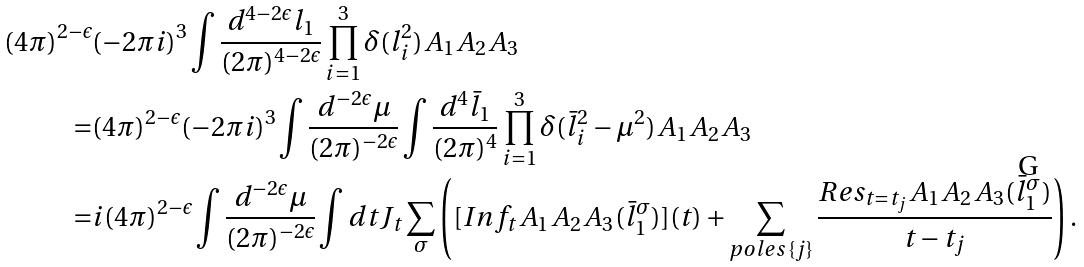<formula> <loc_0><loc_0><loc_500><loc_500>( 4 \pi ) ^ { 2 - \epsilon } & ( - 2 \pi i ) ^ { 3 } \int \frac { d ^ { 4 - 2 \epsilon } l _ { 1 } } { ( 2 \pi ) ^ { 4 - 2 \epsilon } } \prod _ { i = 1 } ^ { 3 } \delta ( l _ { i } ^ { 2 } ) A _ { 1 } A _ { 2 } A _ { 3 } \\ = & ( 4 \pi ) ^ { 2 - \epsilon } ( - 2 \pi i ) ^ { 3 } \int \frac { d ^ { - 2 \epsilon } \mu } { ( 2 \pi ) ^ { - 2 \epsilon } } \int \frac { d ^ { 4 } \bar { l } _ { 1 } } { ( 2 \pi ) ^ { 4 } } \prod _ { i = 1 } ^ { 3 } \delta ( \bar { l } _ { i } ^ { 2 } - \mu ^ { 2 } ) A _ { 1 } A _ { 2 } A _ { 3 } \\ = & i ( 4 \pi ) ^ { 2 - \epsilon } \int \frac { d ^ { - 2 \epsilon } \mu } { ( 2 \pi ) ^ { - 2 \epsilon } } \int d t J _ { t } \sum _ { \sigma } \left ( [ I n f _ { t } A _ { 1 } A _ { 2 } A _ { 3 } ( \bar { l } _ { 1 } ^ { \sigma } ) ] ( t ) + \sum _ { p o l e s \, \{ j \} } \frac { R e s _ { t = t _ { j } } A _ { 1 } A _ { 2 } A _ { 3 } ( \bar { l } _ { 1 } ^ { \sigma } ) } { t - t _ { j } } \right ) .</formula> 